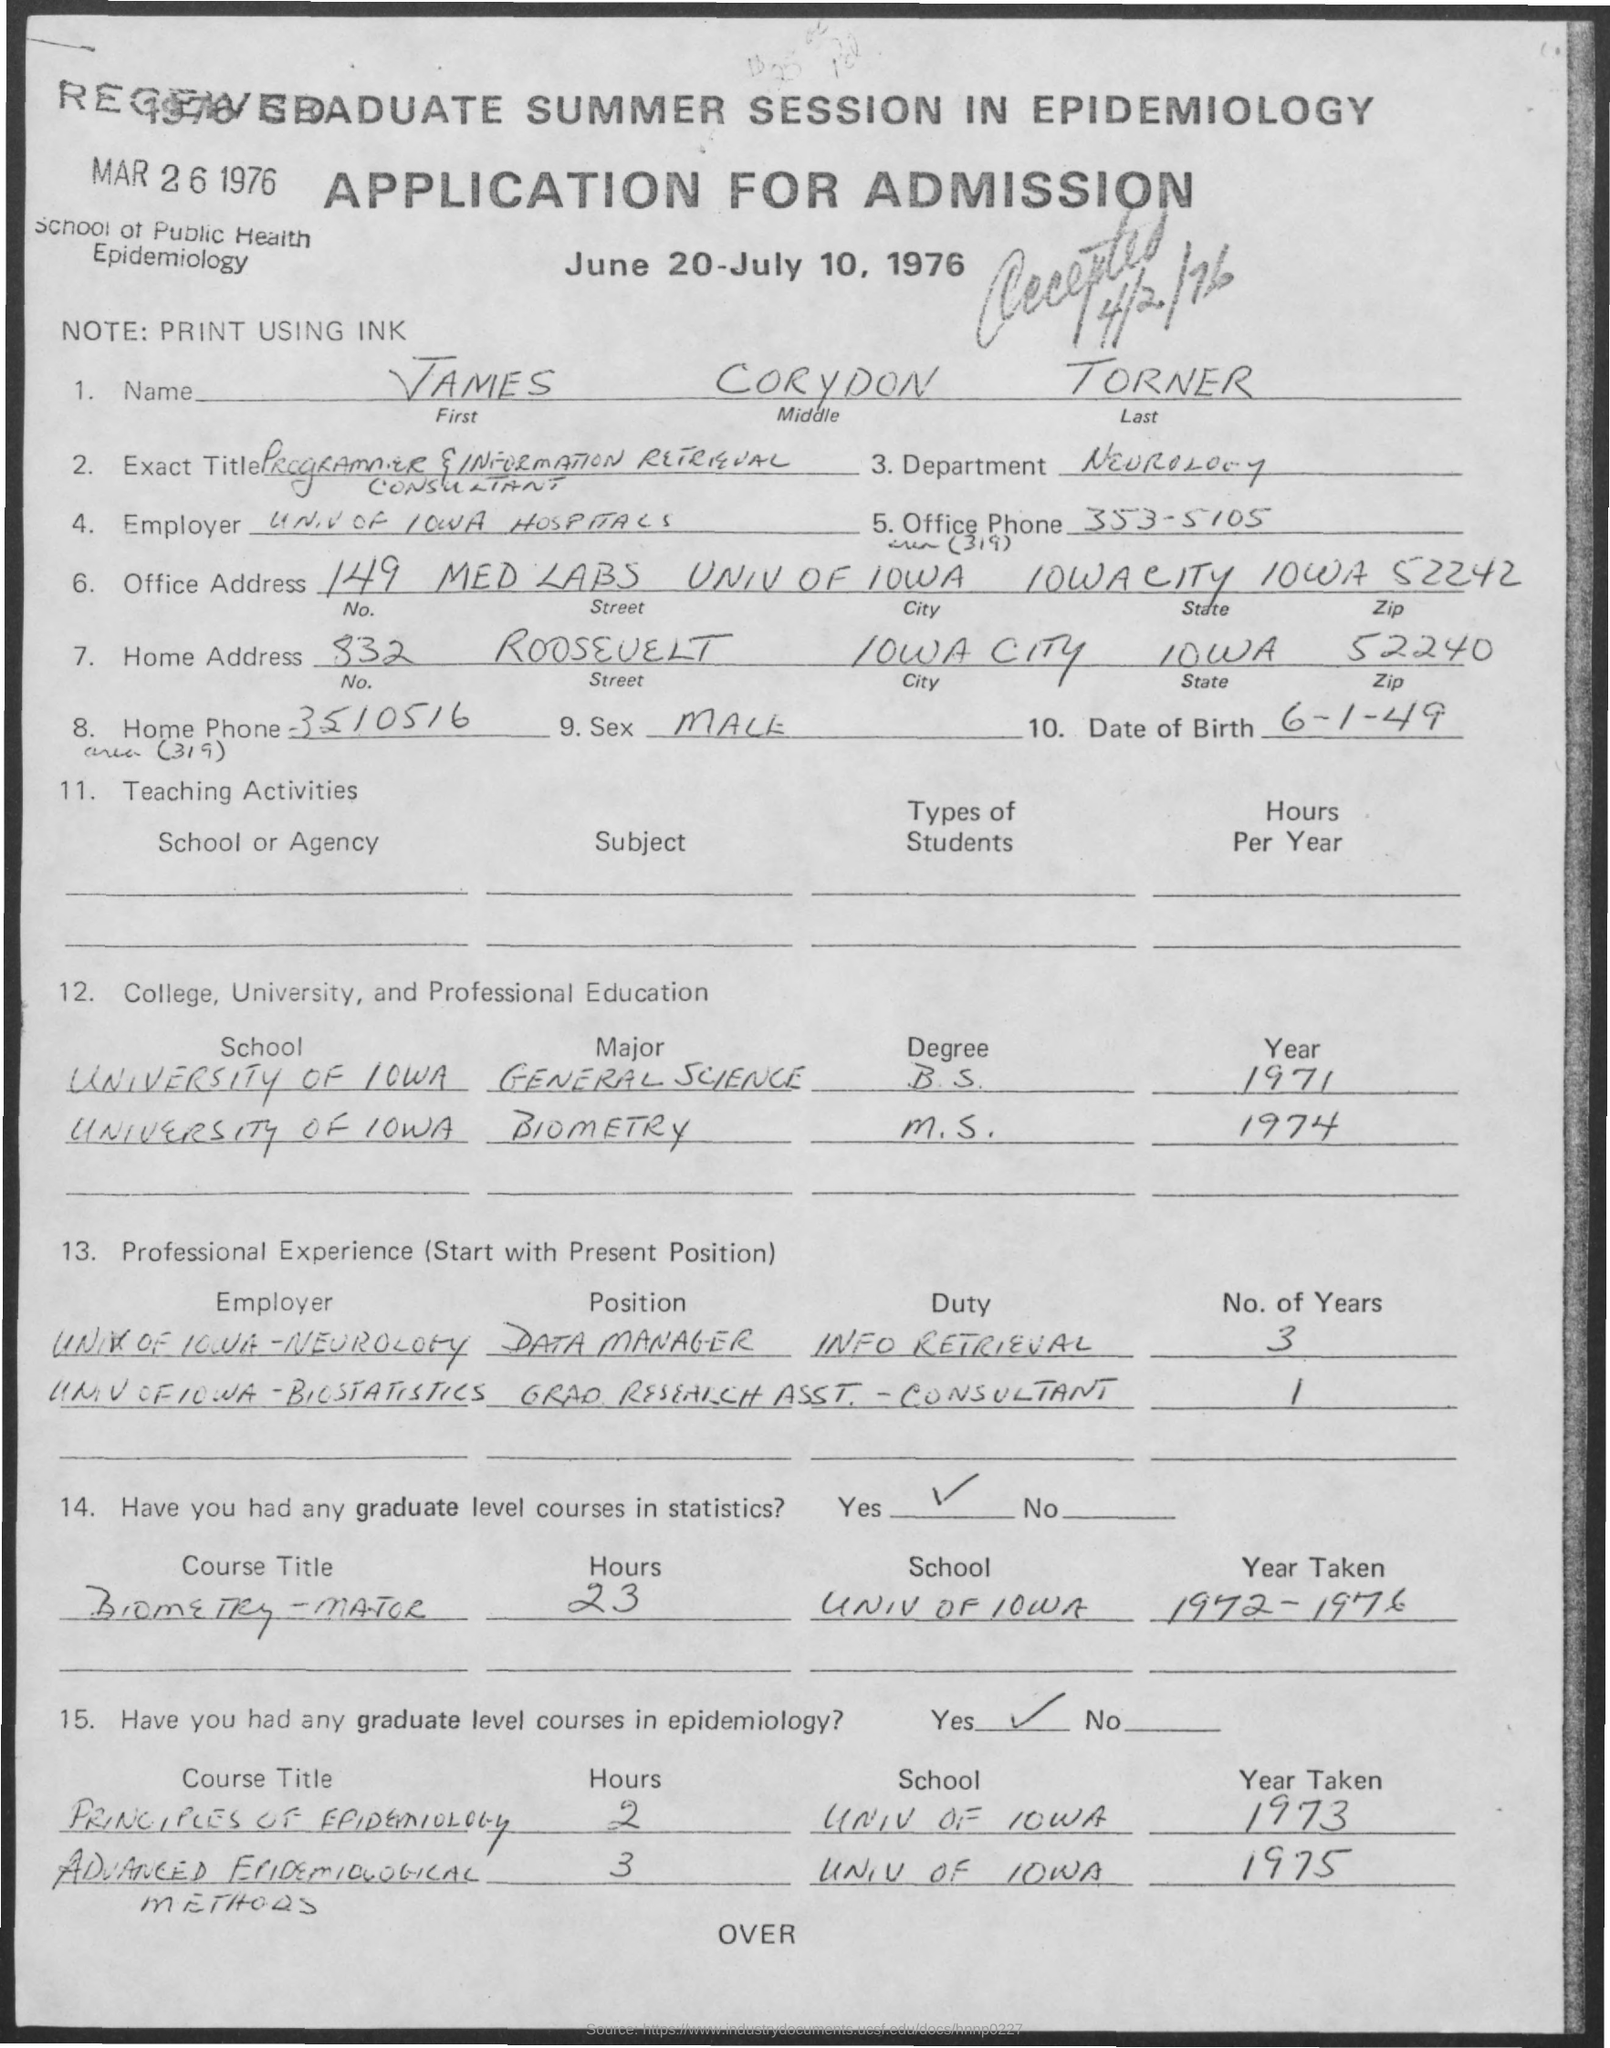List a handful of essential elements in this visual. The name given is James Corydon Turner. The document pertains to an application for admission. The document is dated March 26, 1976. 